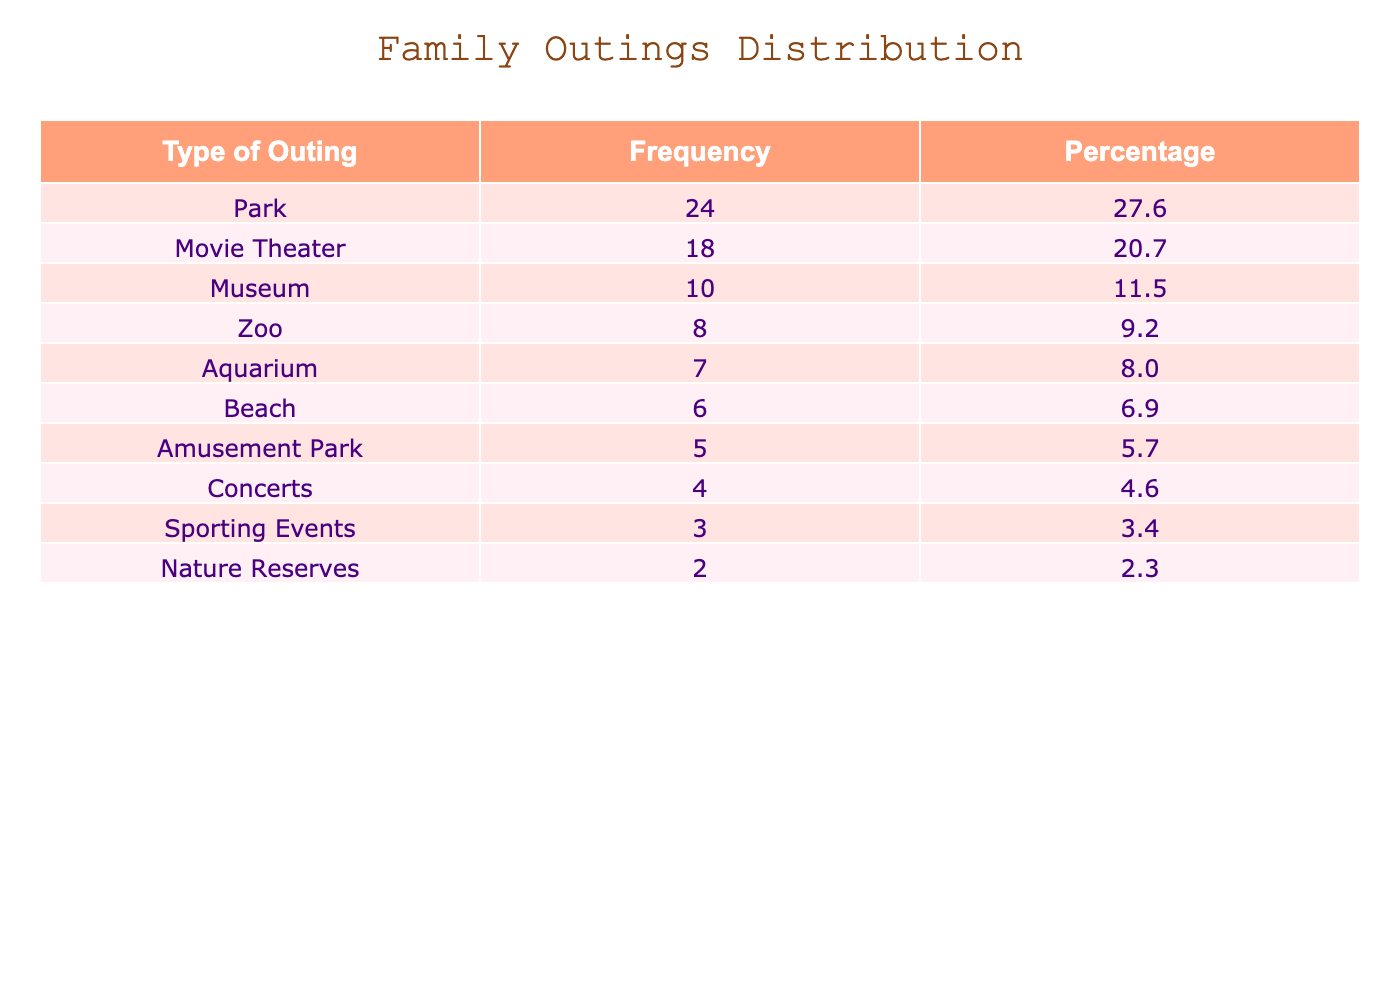What type of outing had the highest frequency? By looking at the "Frequency" column, we can see that "Park" has the highest number of outings at 24. This is greater than any other type listed in the table.
Answer: Park How many outings did we have at the Movie Theater? The table shows that the "Movie Theater" outings totaled 18. Therefore, we can retrieve this specific value directly from the table.
Answer: 18 What is the total number of zoo outings and aquarium outings combined? We look for the "Zoo" and "Aquarium" rows in the table. "Zoo" has 8 outings and "Aquarium" has 7 outings. Adding these two together gives 8 + 7 = 15.
Answer: 15 Are there more outings to parks than to museums? Checking the "Frequency" column, we see that "Park" has 24 outings and "Museum" has 10. Since 24 is greater than 10, the statement is true.
Answer: Yes What percentage of total outings did the Amusement Park represent? First, we find the total number of outings by adding all values from the "Outings" column, which sums up to 100. The "Amusement Park" has 5 outings, so we calculate the percentage as (5 / 100) * 100 = 5%.
Answer: 5% How many more outings were made to movies than to concerts? Reviewing the table, "Movie Theater" has 18 outings while "Concerts" has 4. To find the difference, we subtract: 18 - 4 = 14.
Answer: 14 Are there fewer than 10 outings at the beach? The table indicates that the beach had 6 outings. Since 6 is less than 10, the answer to the question is true.
Answer: Yes What is the average number of outings for each type across all categories displayed? To find the average, we first sum all outings: 24 + 10 + 18 + 8 + 5 + 7 + 6 + 4 + 3 + 2 = 100. There are 10 categories, thus the average is 100 / 10 = 10.
Answer: 10 Which two types of outings have the least frequency, and what are their numbers? By checking the "Frequency" values, "Nature Reserves" has 2 outings and "Sporting Events" has 3 outings, making them the two types with the least frequency.
Answer: Nature Reserves: 2, Sporting Events: 3 